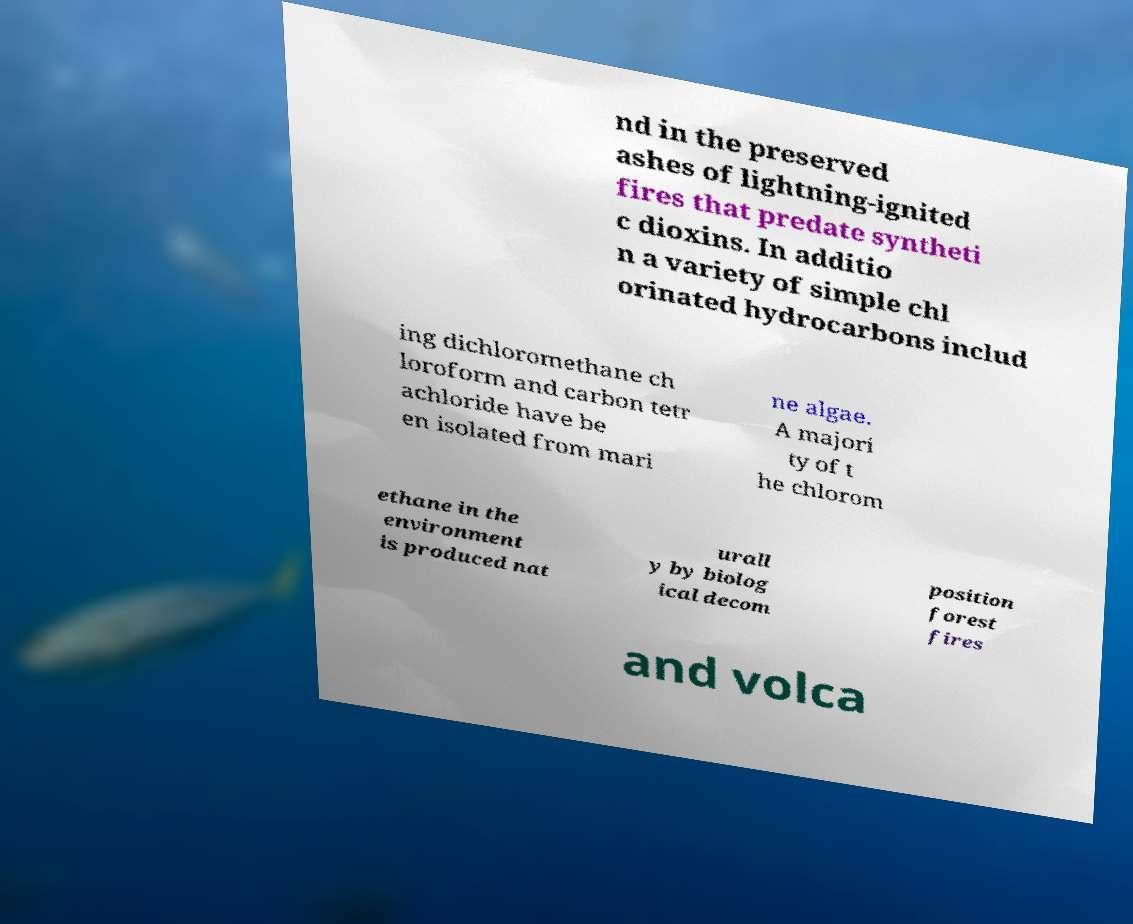For documentation purposes, I need the text within this image transcribed. Could you provide that? nd in the preserved ashes of lightning-ignited fires that predate syntheti c dioxins. In additio n a variety of simple chl orinated hydrocarbons includ ing dichloromethane ch loroform and carbon tetr achloride have be en isolated from mari ne algae. A majori ty of t he chlorom ethane in the environment is produced nat urall y by biolog ical decom position forest fires and volca 